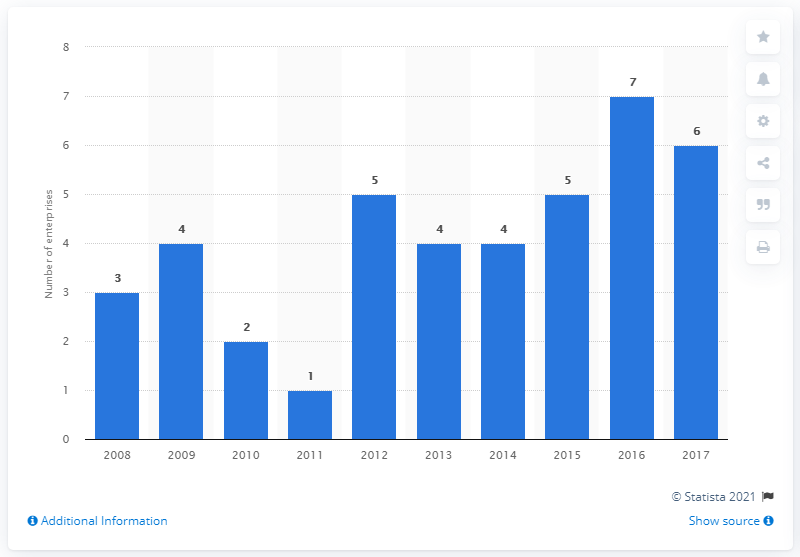What is the average of the two modes?
 4.5 